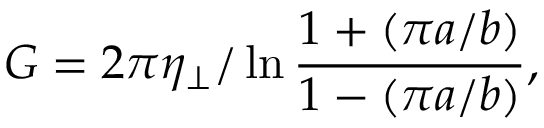Convert formula to latex. <formula><loc_0><loc_0><loc_500><loc_500>G = 2 \pi \eta _ { \perp } / \ln \frac { 1 + ( \pi a / b ) } { 1 - ( \pi a / b ) } ,</formula> 